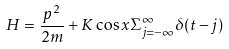<formula> <loc_0><loc_0><loc_500><loc_500>H = \frac { p ^ { 2 } } { 2 m } + K \cos x \Sigma _ { j = - \infty } ^ { \infty } \delta ( t - j )</formula> 